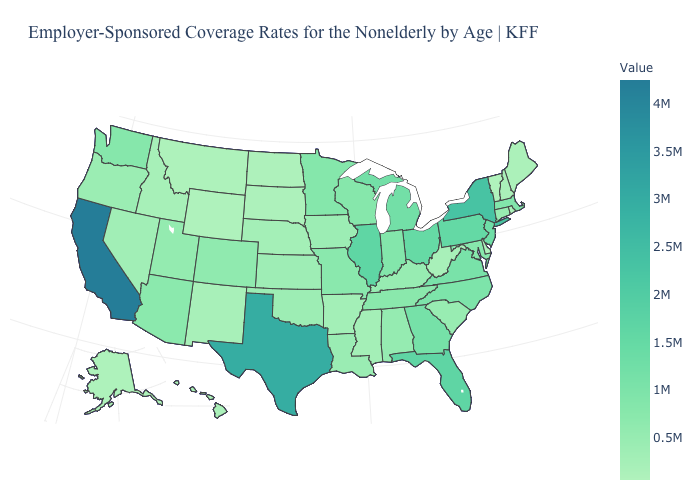Among the states that border New York , which have the lowest value?
Quick response, please. Vermont. Does California have the highest value in the USA?
Be succinct. Yes. Which states have the lowest value in the Northeast?
Quick response, please. Vermont. Does Delaware have the highest value in the USA?
Short answer required. No. Does Utah have a lower value than Alaska?
Keep it brief. No. Which states have the lowest value in the USA?
Be succinct. Vermont. 